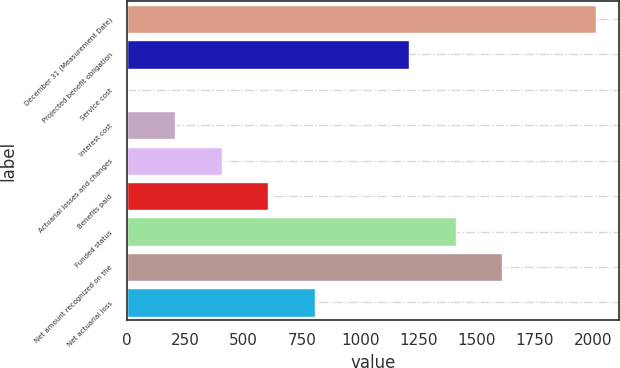Convert chart. <chart><loc_0><loc_0><loc_500><loc_500><bar_chart><fcel>December 31 (Measurement Date)<fcel>Projected benefit obligation<fcel>Service cost<fcel>Interest cost<fcel>Actuarial losses and changes<fcel>Benefits paid<fcel>Funded status<fcel>Net amount recognized on the<fcel>Net actuarial loss<nl><fcel>2011<fcel>1208.2<fcel>4<fcel>204.7<fcel>405.4<fcel>606.1<fcel>1408.9<fcel>1609.6<fcel>806.8<nl></chart> 